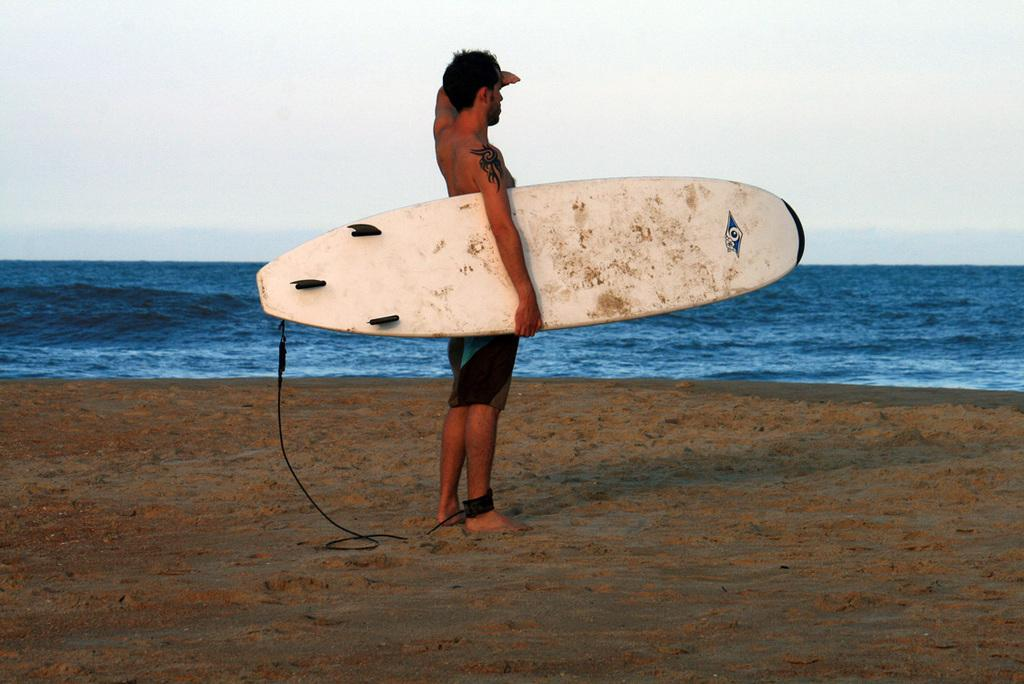What is the weather like in the image? The sky is cloudy in the image. What can be seen in the background of the image? There is water visible in the image. What is the person in the image doing? The person is standing on a stand and holding a surf boat in his hand. What type of fuel is the person using to power the surf boat in the image? There is no indication in the image that the person is using any fuel to power the surf boat, as it is held in his hand and not in use. 